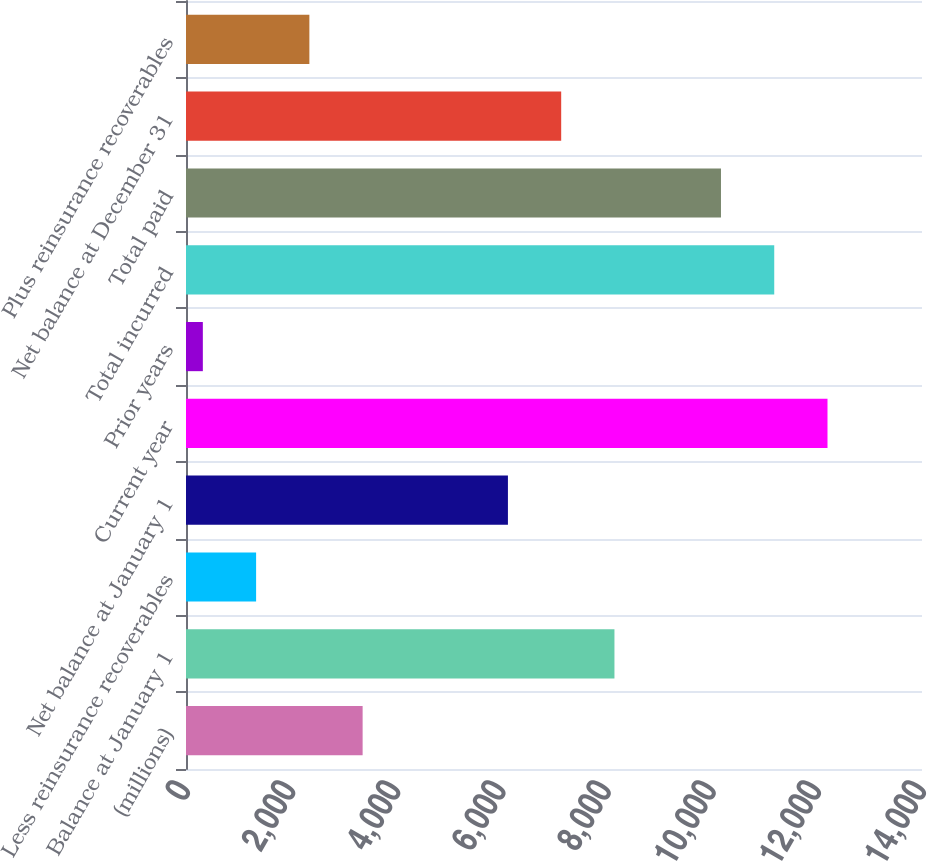<chart> <loc_0><loc_0><loc_500><loc_500><bar_chart><fcel>(millions)<fcel>Balance at January 1<fcel>Less reinsurance recoverables<fcel>Net balance at January 1<fcel>Current year<fcel>Prior years<fcel>Total incurred<fcel>Total paid<fcel>Net balance at December 31<fcel>Plus reinsurance recoverables<nl><fcel>3359.79<fcel>8149.86<fcel>1333.53<fcel>6123.6<fcel>12202.4<fcel>320.4<fcel>11189.2<fcel>10176.1<fcel>7136.73<fcel>2346.66<nl></chart> 